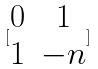<formula> <loc_0><loc_0><loc_500><loc_500>[ \begin{matrix} 0 & 1 \\ 1 & - n \end{matrix} ]</formula> 